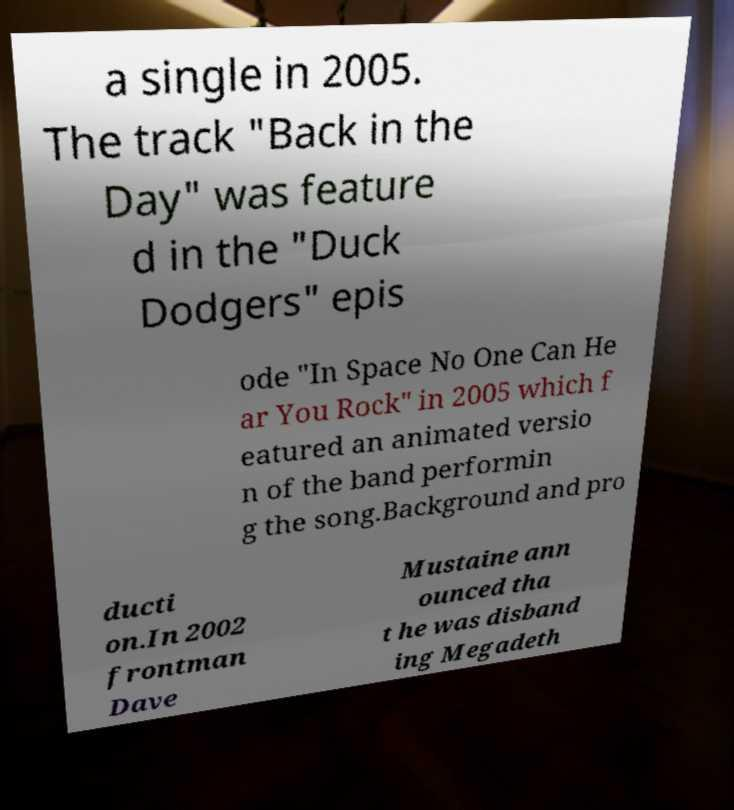Can you accurately transcribe the text from the provided image for me? a single in 2005. The track "Back in the Day" was feature d in the "Duck Dodgers" epis ode "In Space No One Can He ar You Rock" in 2005 which f eatured an animated versio n of the band performin g the song.Background and pro ducti on.In 2002 frontman Dave Mustaine ann ounced tha t he was disband ing Megadeth 